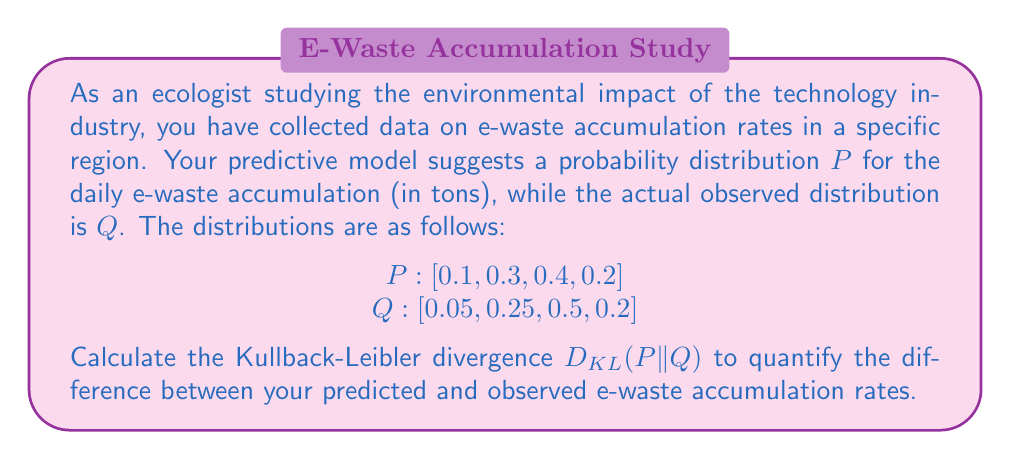Could you help me with this problem? To calculate the Kullback-Leibler divergence between the predicted distribution P and the observed distribution Q, we use the formula:

$$D_{KL}(P||Q) = \sum_{i} P(i) \log\left(\frac{P(i)}{Q(i)}\right)$$

Let's calculate this step-by-step:

1) First, we calculate each term of the sum:

   For i = 1: $0.1 \log\left(\frac{0.1}{0.05}\right) = 0.1 \log(2) \approx 0.0693$
   
   For i = 2: $0.3 \log\left(\frac{0.3}{0.25}\right) = 0.3 \log(1.2) \approx 0.0547$
   
   For i = 3: $0.4 \log\left(\frac{0.4}{0.5}\right) = 0.4 \log(0.8) \approx -0.0374$
   
   For i = 4: $0.2 \log\left(\frac{0.2}{0.2}\right) = 0.2 \log(1) = 0$

2) Now, we sum all these terms:

   $D_{KL}(P||Q) = 0.0693 + 0.0547 - 0.0374 + 0 = 0.0866$

The Kullback-Leibler divergence is approximately 0.0866 nats (natural units of information).

This value quantifies the information lost when Q is used to approximate P. In the context of e-waste accumulation, it indicates how much your predicted distribution differs from the observed distribution. A lower value would indicate a better prediction.
Answer: $D_{KL}(P||Q) \approx 0.0866$ nats 